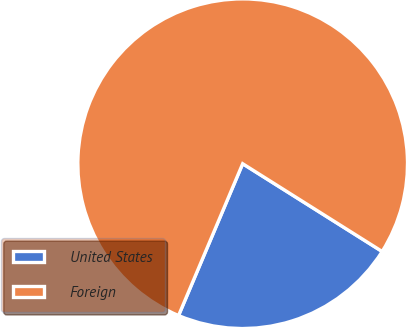Convert chart to OTSL. <chart><loc_0><loc_0><loc_500><loc_500><pie_chart><fcel>United States<fcel>Foreign<nl><fcel>22.42%<fcel>77.58%<nl></chart> 